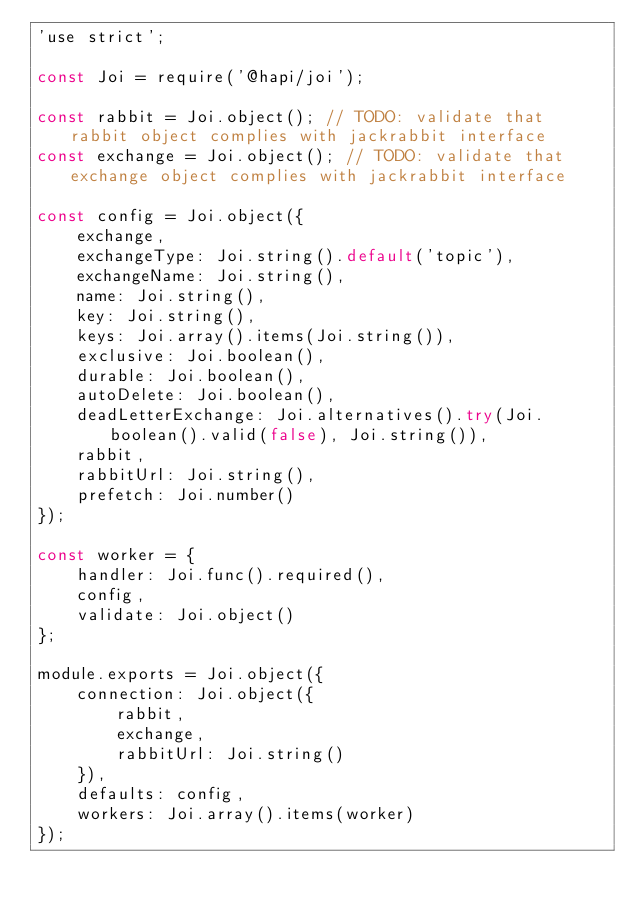Convert code to text. <code><loc_0><loc_0><loc_500><loc_500><_JavaScript_>'use strict';

const Joi = require('@hapi/joi');

const rabbit = Joi.object(); // TODO: validate that rabbit object complies with jackrabbit interface
const exchange = Joi.object(); // TODO: validate that exchange object complies with jackrabbit interface

const config = Joi.object({
    exchange,
    exchangeType: Joi.string().default('topic'),
    exchangeName: Joi.string(),
    name: Joi.string(),
    key: Joi.string(),
    keys: Joi.array().items(Joi.string()),
    exclusive: Joi.boolean(),
    durable: Joi.boolean(),
    autoDelete: Joi.boolean(),
    deadLetterExchange: Joi.alternatives().try(Joi.boolean().valid(false), Joi.string()),
    rabbit,
    rabbitUrl: Joi.string(),
    prefetch: Joi.number()
});

const worker = {
    handler: Joi.func().required(),
    config,
    validate: Joi.object()
};

module.exports = Joi.object({
    connection: Joi.object({
        rabbit,
        exchange,
        rabbitUrl: Joi.string()
    }),
    defaults: config,
    workers: Joi.array().items(worker)
});
</code> 